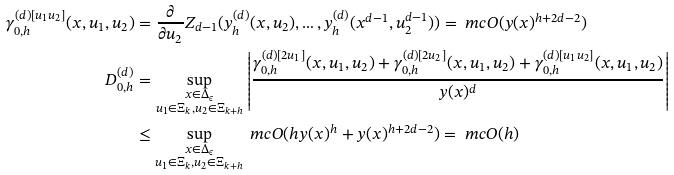Convert formula to latex. <formula><loc_0><loc_0><loc_500><loc_500>\gamma _ { 0 , h } ^ { ( d ) [ u _ { 1 } u _ { 2 } ] } ( x , u _ { 1 } , u _ { 2 } ) & = \frac { \partial } { \partial u _ { 2 } } Z _ { d - 1 } ( y _ { h } ^ { ( d ) } ( x , u _ { 2 } ) , \dots , y _ { h } ^ { ( d ) } ( x ^ { d - 1 } , u _ { 2 } ^ { d - 1 } ) ) = \ m c { O } ( y ( x ) ^ { h + 2 d - 2 } ) \\ D _ { 0 , h } ^ { ( d ) } & = \sup _ { \substack { x \in \Delta _ { \epsilon } \\ u _ { 1 } \in \Xi _ { k } , u _ { 2 } \in \Xi _ { k + h } } } \left | \frac { \gamma _ { 0 , h } ^ { ( d ) [ 2 u _ { 1 } ] } ( x , u _ { 1 } , u _ { 2 } ) + \gamma _ { 0 , h } ^ { ( d ) [ 2 u _ { 2 } ] } ( x , u _ { 1 } , u _ { 2 } ) + \gamma _ { 0 , h } ^ { ( d ) [ u _ { 1 } u _ { 2 } ] } ( x , u _ { 1 } , u _ { 2 } ) } { y ( x ) ^ { d } } \right | \\ & \leq \sup _ { \substack { x \in \Delta _ { \epsilon } \\ u _ { 1 } \in \Xi _ { k } , u _ { 2 } \in \Xi _ { k + h } } } \ m c { O } ( h y ( x ) ^ { h } + y ( x ) ^ { h + 2 d - 2 } ) = \ m c { O } ( h )</formula> 